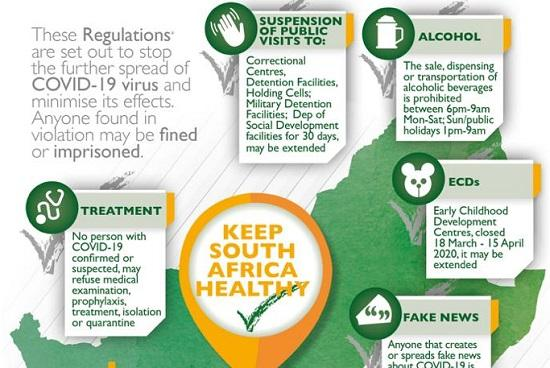Identify some key points in this picture. The infographic lists the third place that has not been visited as holding cells. The infographic lists the Department of Social Development facilities as the fifth place that has not been visited. Is this correct? 